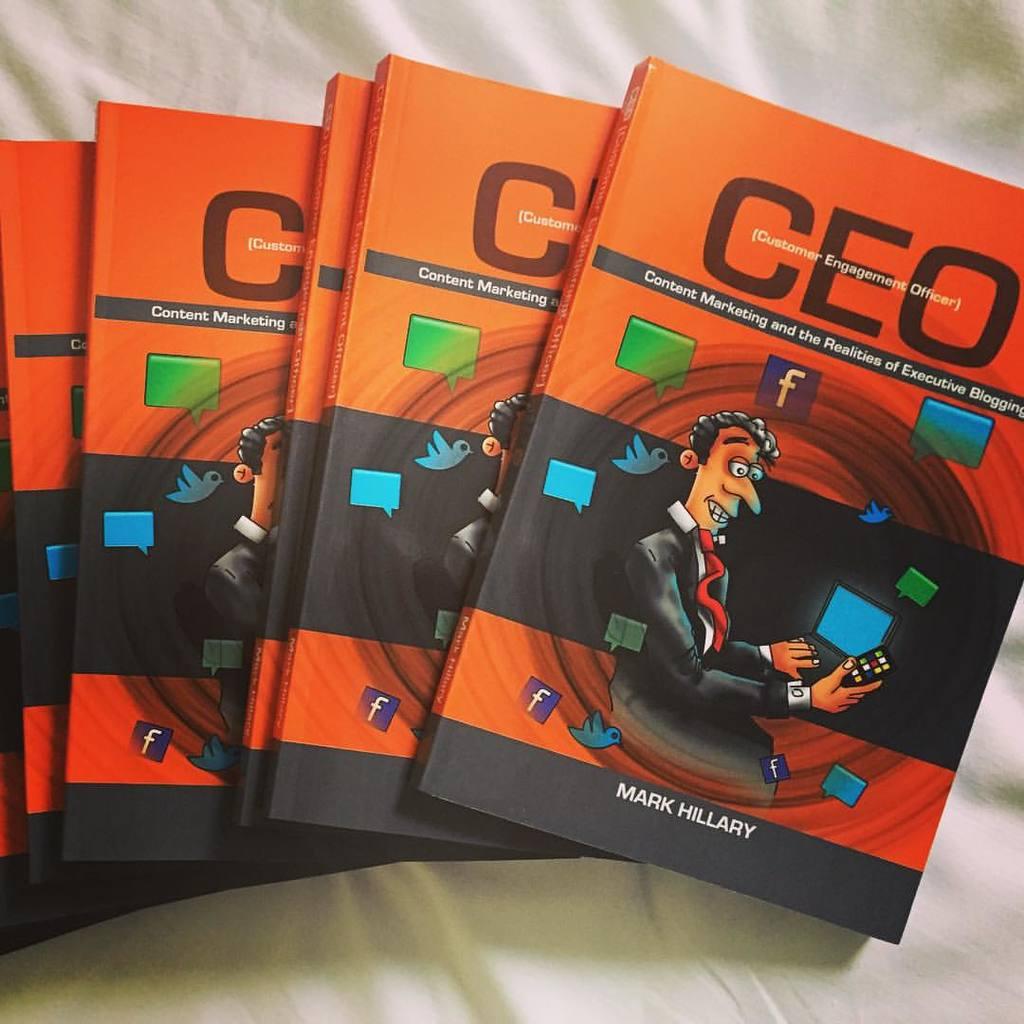Who wrote this book?
Provide a short and direct response. Mark hillary. What is the title of this book?
Your answer should be very brief. Ceo. 